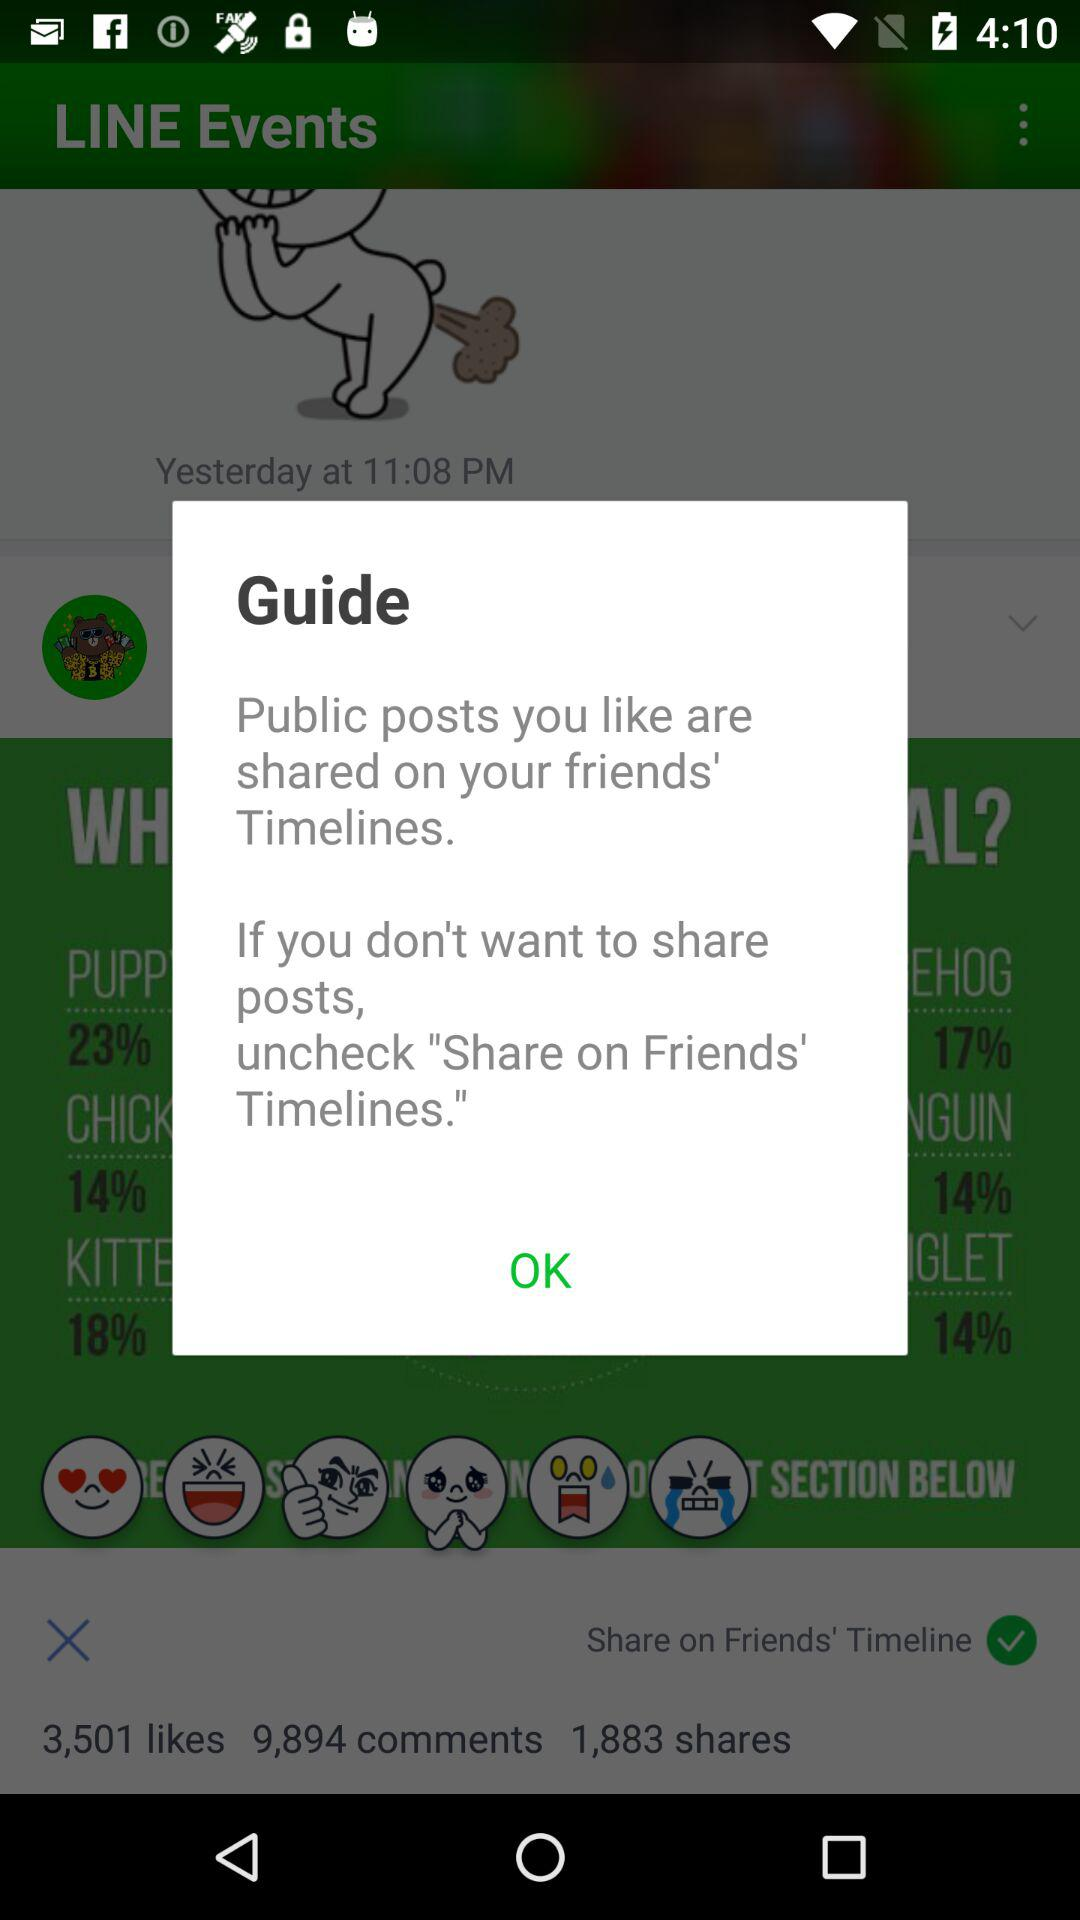How many likes are there? There are 3,501 likes. 